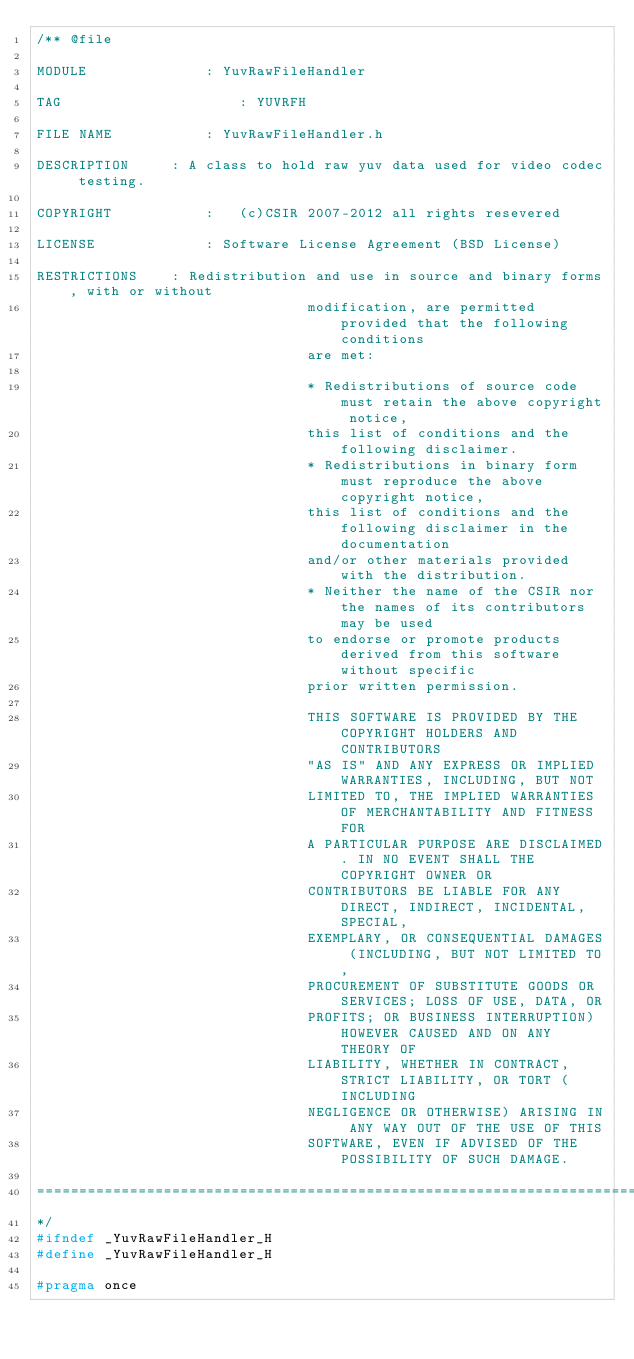<code> <loc_0><loc_0><loc_500><loc_500><_C_>/** @file

MODULE				: YuvRawFileHandler

TAG						: YUVRFH

FILE NAME			: YuvRawFileHandler.h

DESCRIPTION		: A class to hold raw yuv data used for video codec testing.

COPYRIGHT			:	(c)CSIR 2007-2012 all rights resevered

LICENSE				: Software License Agreement (BSD License)

RESTRICTIONS	: Redistribution and use in source and binary forms, with or without 
								modification, are permitted provided that the following conditions 
								are met:

								* Redistributions of source code must retain the above copyright notice, 
								this list of conditions and the following disclaimer.
								* Redistributions in binary form must reproduce the above copyright notice, 
								this list of conditions and the following disclaimer in the documentation 
								and/or other materials provided with the distribution.
								* Neither the name of the CSIR nor the names of its contributors may be used 
								to endorse or promote products derived from this software without specific 
								prior written permission.

								THIS SOFTWARE IS PROVIDED BY THE COPYRIGHT HOLDERS AND CONTRIBUTORS
								"AS IS" AND ANY EXPRESS OR IMPLIED WARRANTIES, INCLUDING, BUT NOT
								LIMITED TO, THE IMPLIED WARRANTIES OF MERCHANTABILITY AND FITNESS FOR
								A PARTICULAR PURPOSE ARE DISCLAIMED. IN NO EVENT SHALL THE COPYRIGHT OWNER OR
								CONTRIBUTORS BE LIABLE FOR ANY DIRECT, INDIRECT, INCIDENTAL, SPECIAL,
								EXEMPLARY, OR CONSEQUENTIAL DAMAGES (INCLUDING, BUT NOT LIMITED TO,
								PROCUREMENT OF SUBSTITUTE GOODS OR SERVICES; LOSS OF USE, DATA, OR
								PROFITS; OR BUSINESS INTERRUPTION) HOWEVER CAUSED AND ON ANY THEORY OF
								LIABILITY, WHETHER IN CONTRACT, STRICT LIABILITY, OR TORT (INCLUDING
								NEGLIGENCE OR OTHERWISE) ARISING IN ANY WAY OUT OF THE USE OF THIS
								SOFTWARE, EVEN IF ADVISED OF THE POSSIBILITY OF SUCH DAMAGE.

=========================================================================================
*/
#ifndef _YuvRawFileHandler_H
#define _YuvRawFileHandler_H

#pragma once
</code> 